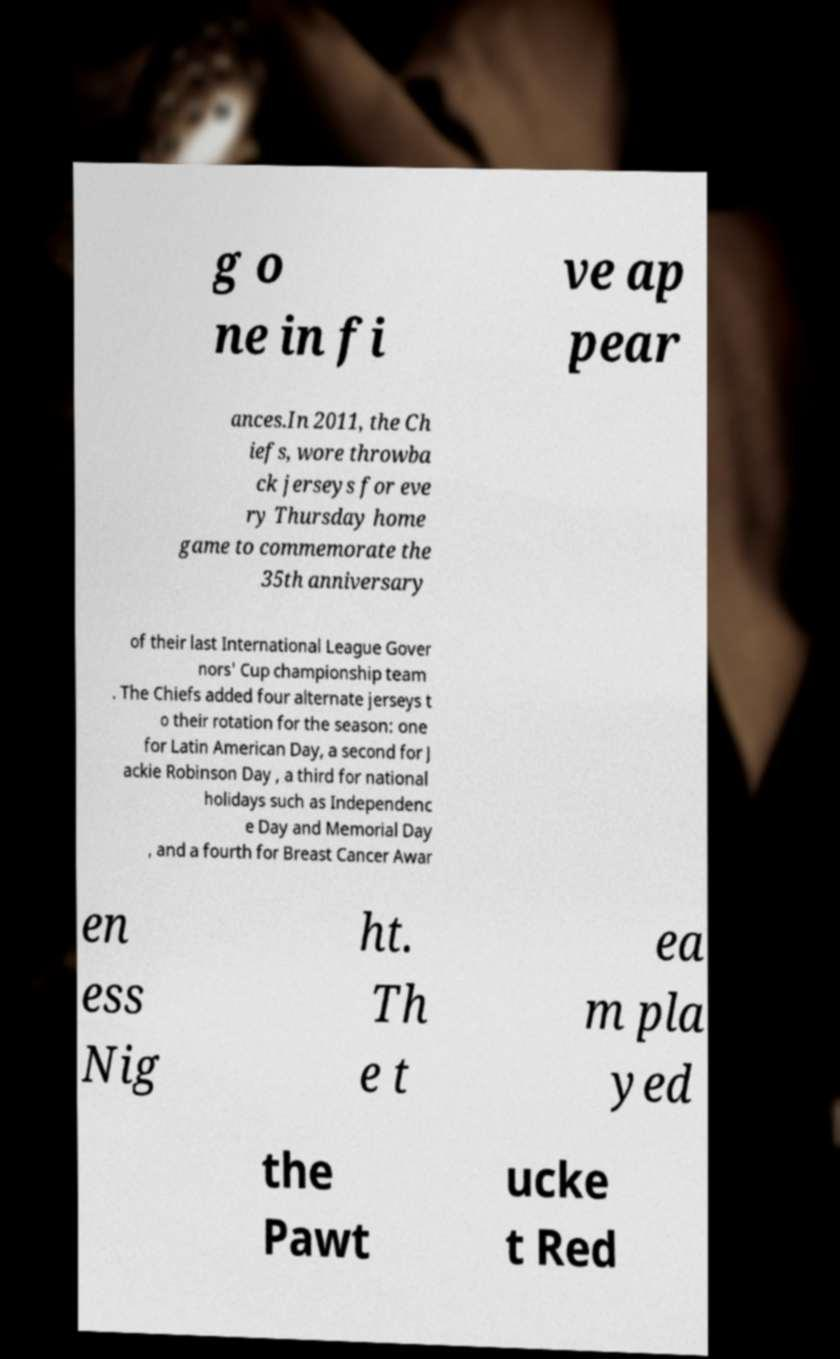Please read and relay the text visible in this image. What does it say? g o ne in fi ve ap pear ances.In 2011, the Ch iefs, wore throwba ck jerseys for eve ry Thursday home game to commemorate the 35th anniversary of their last International League Gover nors' Cup championship team . The Chiefs added four alternate jerseys t o their rotation for the season: one for Latin American Day, a second for J ackie Robinson Day , a third for national holidays such as Independenc e Day and Memorial Day , and a fourth for Breast Cancer Awar en ess Nig ht. Th e t ea m pla yed the Pawt ucke t Red 